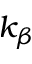<formula> <loc_0><loc_0><loc_500><loc_500>k _ { \beta }</formula> 